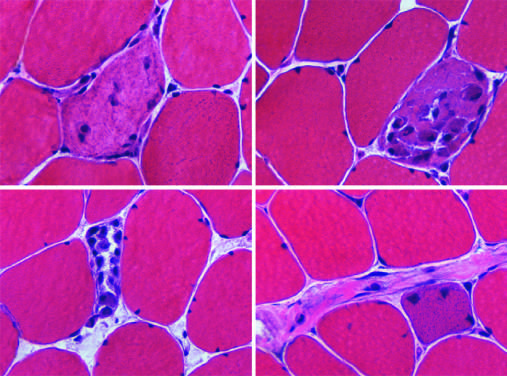re congenital capillary hemangioma at 2 years of age after the lesion characterized by cytoplasmic basophilia and enlarged nucleoli not visible at this power?
Answer the question using a single word or phrase. No 